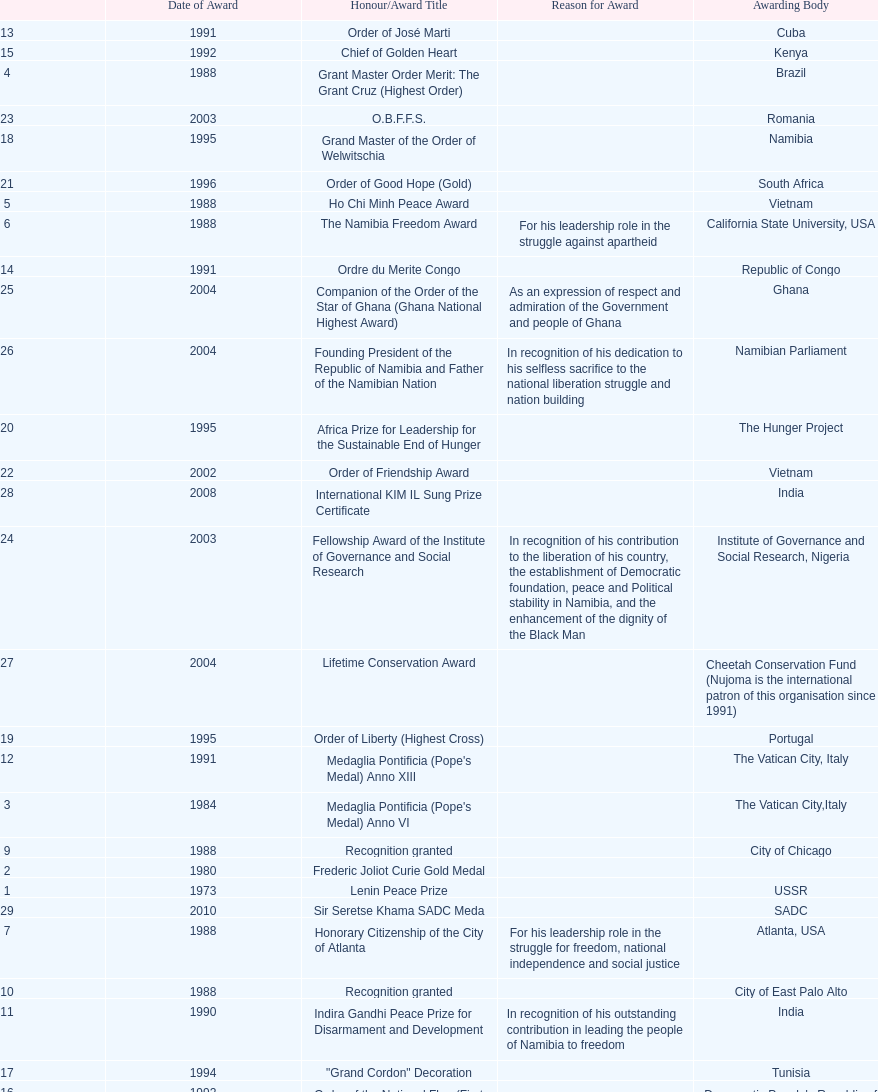Which year was the most honors/award titles given? 1988. 